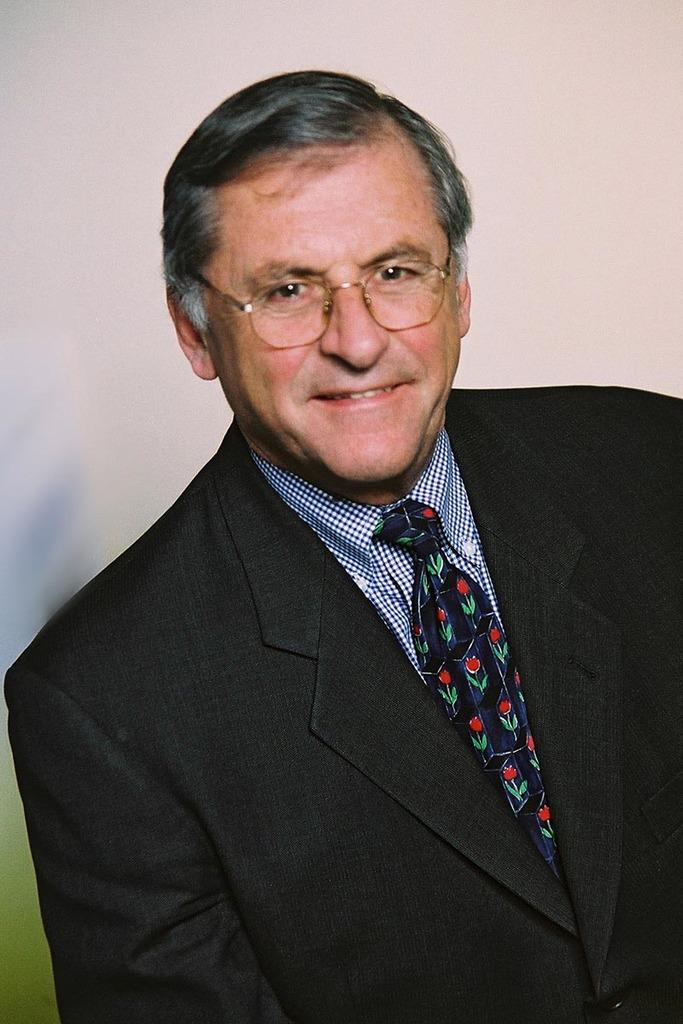Who is the main subject in the image? There is a person in the center of the image. What is the person wearing? The person is wearing a suit. What can be seen in the background of the image? There is a wall in the background of the image. What type of canvas is the person painting on in the image? There is no canvas or painting activity present in the image. How does the person look in the image? The image does not provide a description of the person's appearance or facial expression. 